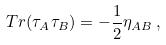Convert formula to latex. <formula><loc_0><loc_0><loc_500><loc_500>{ T r } ( \tau _ { A } \tau _ { B } ) = - \frac { 1 } { 2 } \eta _ { A B } \, ,</formula> 